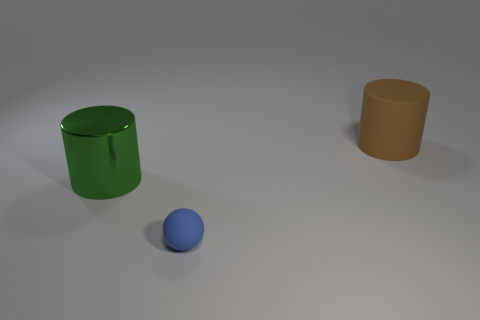Is the number of rubber things to the left of the large green metallic cylinder less than the number of big cyan metal objects? Yes, indeed, the number of rubber items, in this case, observable as a single blue rubber ball to the left of the green metallic cylinder, is less than the number of large cyan metal objects, as there are no cyan metal objects present in this image. 